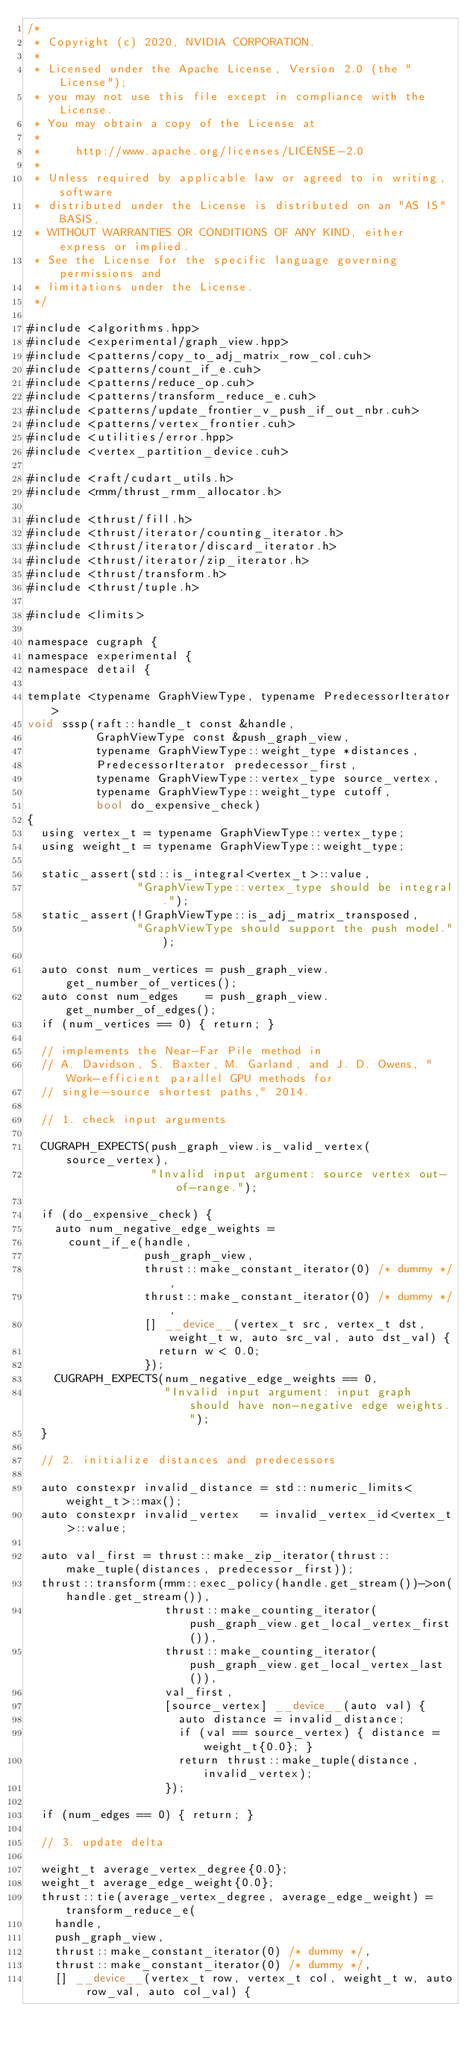Convert code to text. <code><loc_0><loc_0><loc_500><loc_500><_Cuda_>/*
 * Copyright (c) 2020, NVIDIA CORPORATION.
 *
 * Licensed under the Apache License, Version 2.0 (the "License");
 * you may not use this file except in compliance with the License.
 * You may obtain a copy of the License at
 *
 *     http://www.apache.org/licenses/LICENSE-2.0
 *
 * Unless required by applicable law or agreed to in writing, software
 * distributed under the License is distributed on an "AS IS" BASIS,
 * WITHOUT WARRANTIES OR CONDITIONS OF ANY KIND, either express or implied.
 * See the License for the specific language governing permissions and
 * limitations under the License.
 */

#include <algorithms.hpp>
#include <experimental/graph_view.hpp>
#include <patterns/copy_to_adj_matrix_row_col.cuh>
#include <patterns/count_if_e.cuh>
#include <patterns/reduce_op.cuh>
#include <patterns/transform_reduce_e.cuh>
#include <patterns/update_frontier_v_push_if_out_nbr.cuh>
#include <patterns/vertex_frontier.cuh>
#include <utilities/error.hpp>
#include <vertex_partition_device.cuh>

#include <raft/cudart_utils.h>
#include <rmm/thrust_rmm_allocator.h>

#include <thrust/fill.h>
#include <thrust/iterator/counting_iterator.h>
#include <thrust/iterator/discard_iterator.h>
#include <thrust/iterator/zip_iterator.h>
#include <thrust/transform.h>
#include <thrust/tuple.h>

#include <limits>

namespace cugraph {
namespace experimental {
namespace detail {

template <typename GraphViewType, typename PredecessorIterator>
void sssp(raft::handle_t const &handle,
          GraphViewType const &push_graph_view,
          typename GraphViewType::weight_type *distances,
          PredecessorIterator predecessor_first,
          typename GraphViewType::vertex_type source_vertex,
          typename GraphViewType::weight_type cutoff,
          bool do_expensive_check)
{
  using vertex_t = typename GraphViewType::vertex_type;
  using weight_t = typename GraphViewType::weight_type;

  static_assert(std::is_integral<vertex_t>::value,
                "GraphViewType::vertex_type should be integral.");
  static_assert(!GraphViewType::is_adj_matrix_transposed,
                "GraphViewType should support the push model.");

  auto const num_vertices = push_graph_view.get_number_of_vertices();
  auto const num_edges    = push_graph_view.get_number_of_edges();
  if (num_vertices == 0) { return; }

  // implements the Near-Far Pile method in
  // A. Davidson, S. Baxter, M. Garland, and J. D. Owens, "Work-efficient parallel GPU methods for
  // single-source shortest paths," 2014.

  // 1. check input arguments

  CUGRAPH_EXPECTS(push_graph_view.is_valid_vertex(source_vertex),
                  "Invalid input argument: source vertex out-of-range.");

  if (do_expensive_check) {
    auto num_negative_edge_weights =
      count_if_e(handle,
                 push_graph_view,
                 thrust::make_constant_iterator(0) /* dummy */,
                 thrust::make_constant_iterator(0) /* dummy */,
                 [] __device__(vertex_t src, vertex_t dst, weight_t w, auto src_val, auto dst_val) {
                   return w < 0.0;
                 });
    CUGRAPH_EXPECTS(num_negative_edge_weights == 0,
                    "Invalid input argument: input graph should have non-negative edge weights.");
  }

  // 2. initialize distances and predecessors

  auto constexpr invalid_distance = std::numeric_limits<weight_t>::max();
  auto constexpr invalid_vertex   = invalid_vertex_id<vertex_t>::value;

  auto val_first = thrust::make_zip_iterator(thrust::make_tuple(distances, predecessor_first));
  thrust::transform(rmm::exec_policy(handle.get_stream())->on(handle.get_stream()),
                    thrust::make_counting_iterator(push_graph_view.get_local_vertex_first()),
                    thrust::make_counting_iterator(push_graph_view.get_local_vertex_last()),
                    val_first,
                    [source_vertex] __device__(auto val) {
                      auto distance = invalid_distance;
                      if (val == source_vertex) { distance = weight_t{0.0}; }
                      return thrust::make_tuple(distance, invalid_vertex);
                    });

  if (num_edges == 0) { return; }

  // 3. update delta

  weight_t average_vertex_degree{0.0};
  weight_t average_edge_weight{0.0};
  thrust::tie(average_vertex_degree, average_edge_weight) = transform_reduce_e(
    handle,
    push_graph_view,
    thrust::make_constant_iterator(0) /* dummy */,
    thrust::make_constant_iterator(0) /* dummy */,
    [] __device__(vertex_t row, vertex_t col, weight_t w, auto row_val, auto col_val) {</code> 